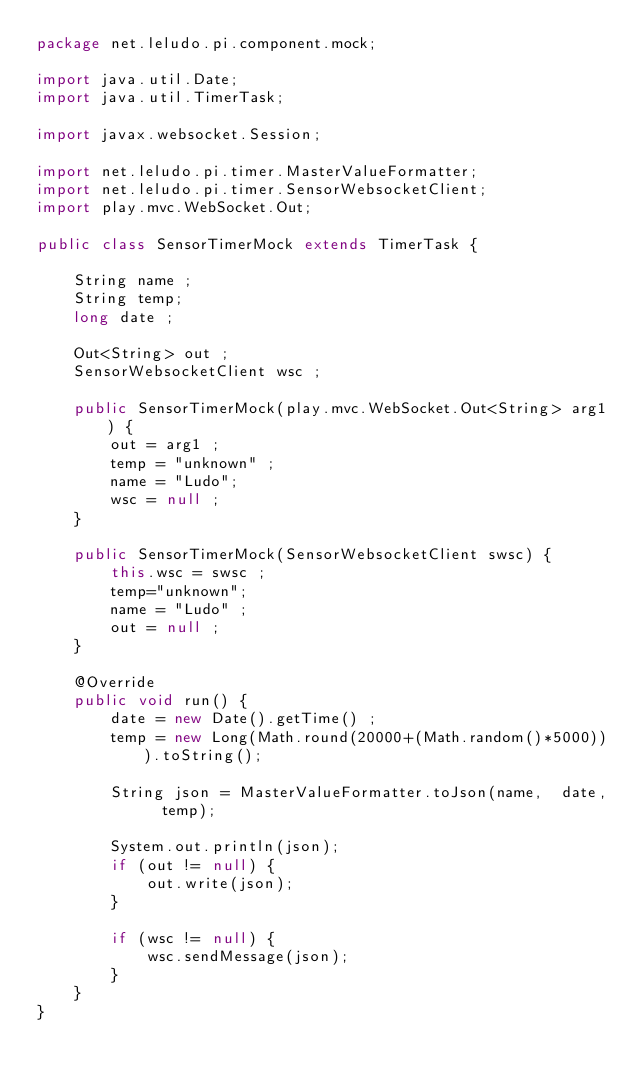<code> <loc_0><loc_0><loc_500><loc_500><_Java_>package net.leludo.pi.component.mock;

import java.util.Date;
import java.util.TimerTask;

import javax.websocket.Session;

import net.leludo.pi.timer.MasterValueFormatter;
import net.leludo.pi.timer.SensorWebsocketClient;
import play.mvc.WebSocket.Out;

public class SensorTimerMock extends TimerTask {

	String name ;
	String temp;
	long date ;
	
	Out<String> out ;
	SensorWebsocketClient wsc ;

	public SensorTimerMock(play.mvc.WebSocket.Out<String> arg1) {
		out = arg1 ;
		temp = "unknown" ;
		name = "Ludo";
		wsc = null ;
	}
	
	public SensorTimerMock(SensorWebsocketClient swsc) {
		this.wsc = swsc ;
		temp="unknown";
		name = "Ludo" ;
		out = null ;
	}

	@Override
	public void run() {
		date = new Date().getTime() ;
		temp = new Long(Math.round(20000+(Math.random()*5000))).toString();
		
		String json = MasterValueFormatter.toJson(name,  date,  temp);
				
		System.out.println(json);
		if (out != null) {
			out.write(json);
		} 
		
		if (wsc != null) {
			wsc.sendMessage(json);
		}
	}
}
</code> 